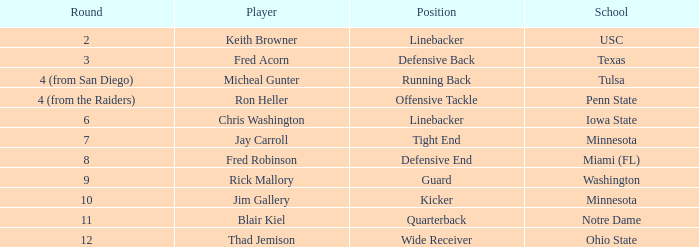What position does thad jemison hold? Wide Receiver. 